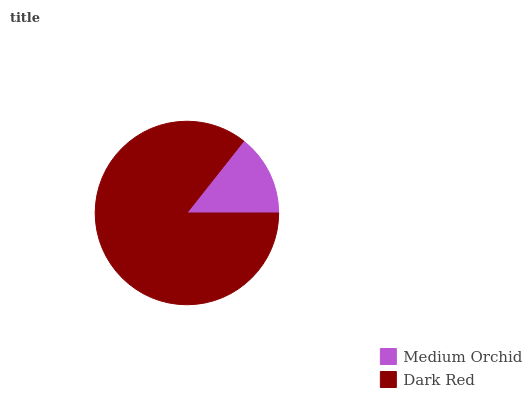Is Medium Orchid the minimum?
Answer yes or no. Yes. Is Dark Red the maximum?
Answer yes or no. Yes. Is Dark Red the minimum?
Answer yes or no. No. Is Dark Red greater than Medium Orchid?
Answer yes or no. Yes. Is Medium Orchid less than Dark Red?
Answer yes or no. Yes. Is Medium Orchid greater than Dark Red?
Answer yes or no. No. Is Dark Red less than Medium Orchid?
Answer yes or no. No. Is Dark Red the high median?
Answer yes or no. Yes. Is Medium Orchid the low median?
Answer yes or no. Yes. Is Medium Orchid the high median?
Answer yes or no. No. Is Dark Red the low median?
Answer yes or no. No. 